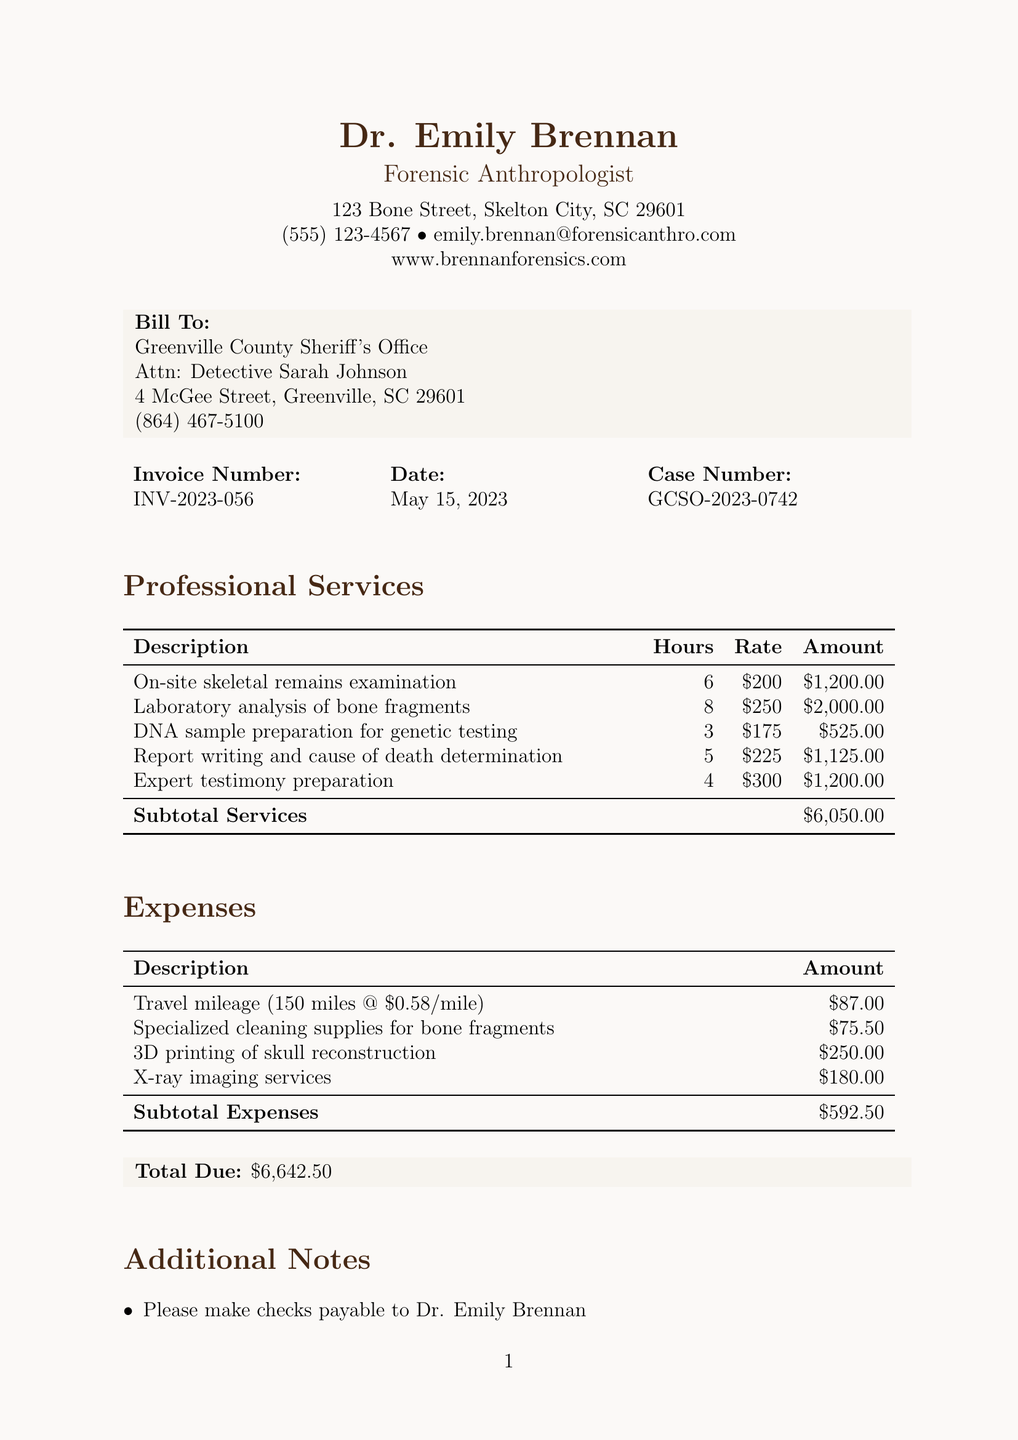What is the professional's name? The document lists the professional's name as Dr. Emily Brennan.
Answer: Dr. Emily Brennan What is the invoice number? The invoice number is explicitly stated in the document.
Answer: INV-2023-056 How much is the total due? The total due is calculated from the subtotal of services and expenses listed in the document.
Answer: $6,642.50 What is the hourly rate for laboratory analysis of bone fragments? This rate can be found in the services section of the invoice.
Answer: $250 What is the case number? The case number is provided in the client information section.
Answer: GCSO-2023-0742 What total amount was charged for expert testimony preparation? The amount is specified alongside the description of the service.
Answer: $1,200.00 How many hours were billed for report writing and cause of death determination? The document specifies the hours next to the service description.
Answer: 5 What is the payment term specified in the invoice? The payment terms are outlined clearly in the document.
Answer: Net 30 What is the total amount for travel mileage? This specific amount is listed under the expenses section.
Answer: $87.00 